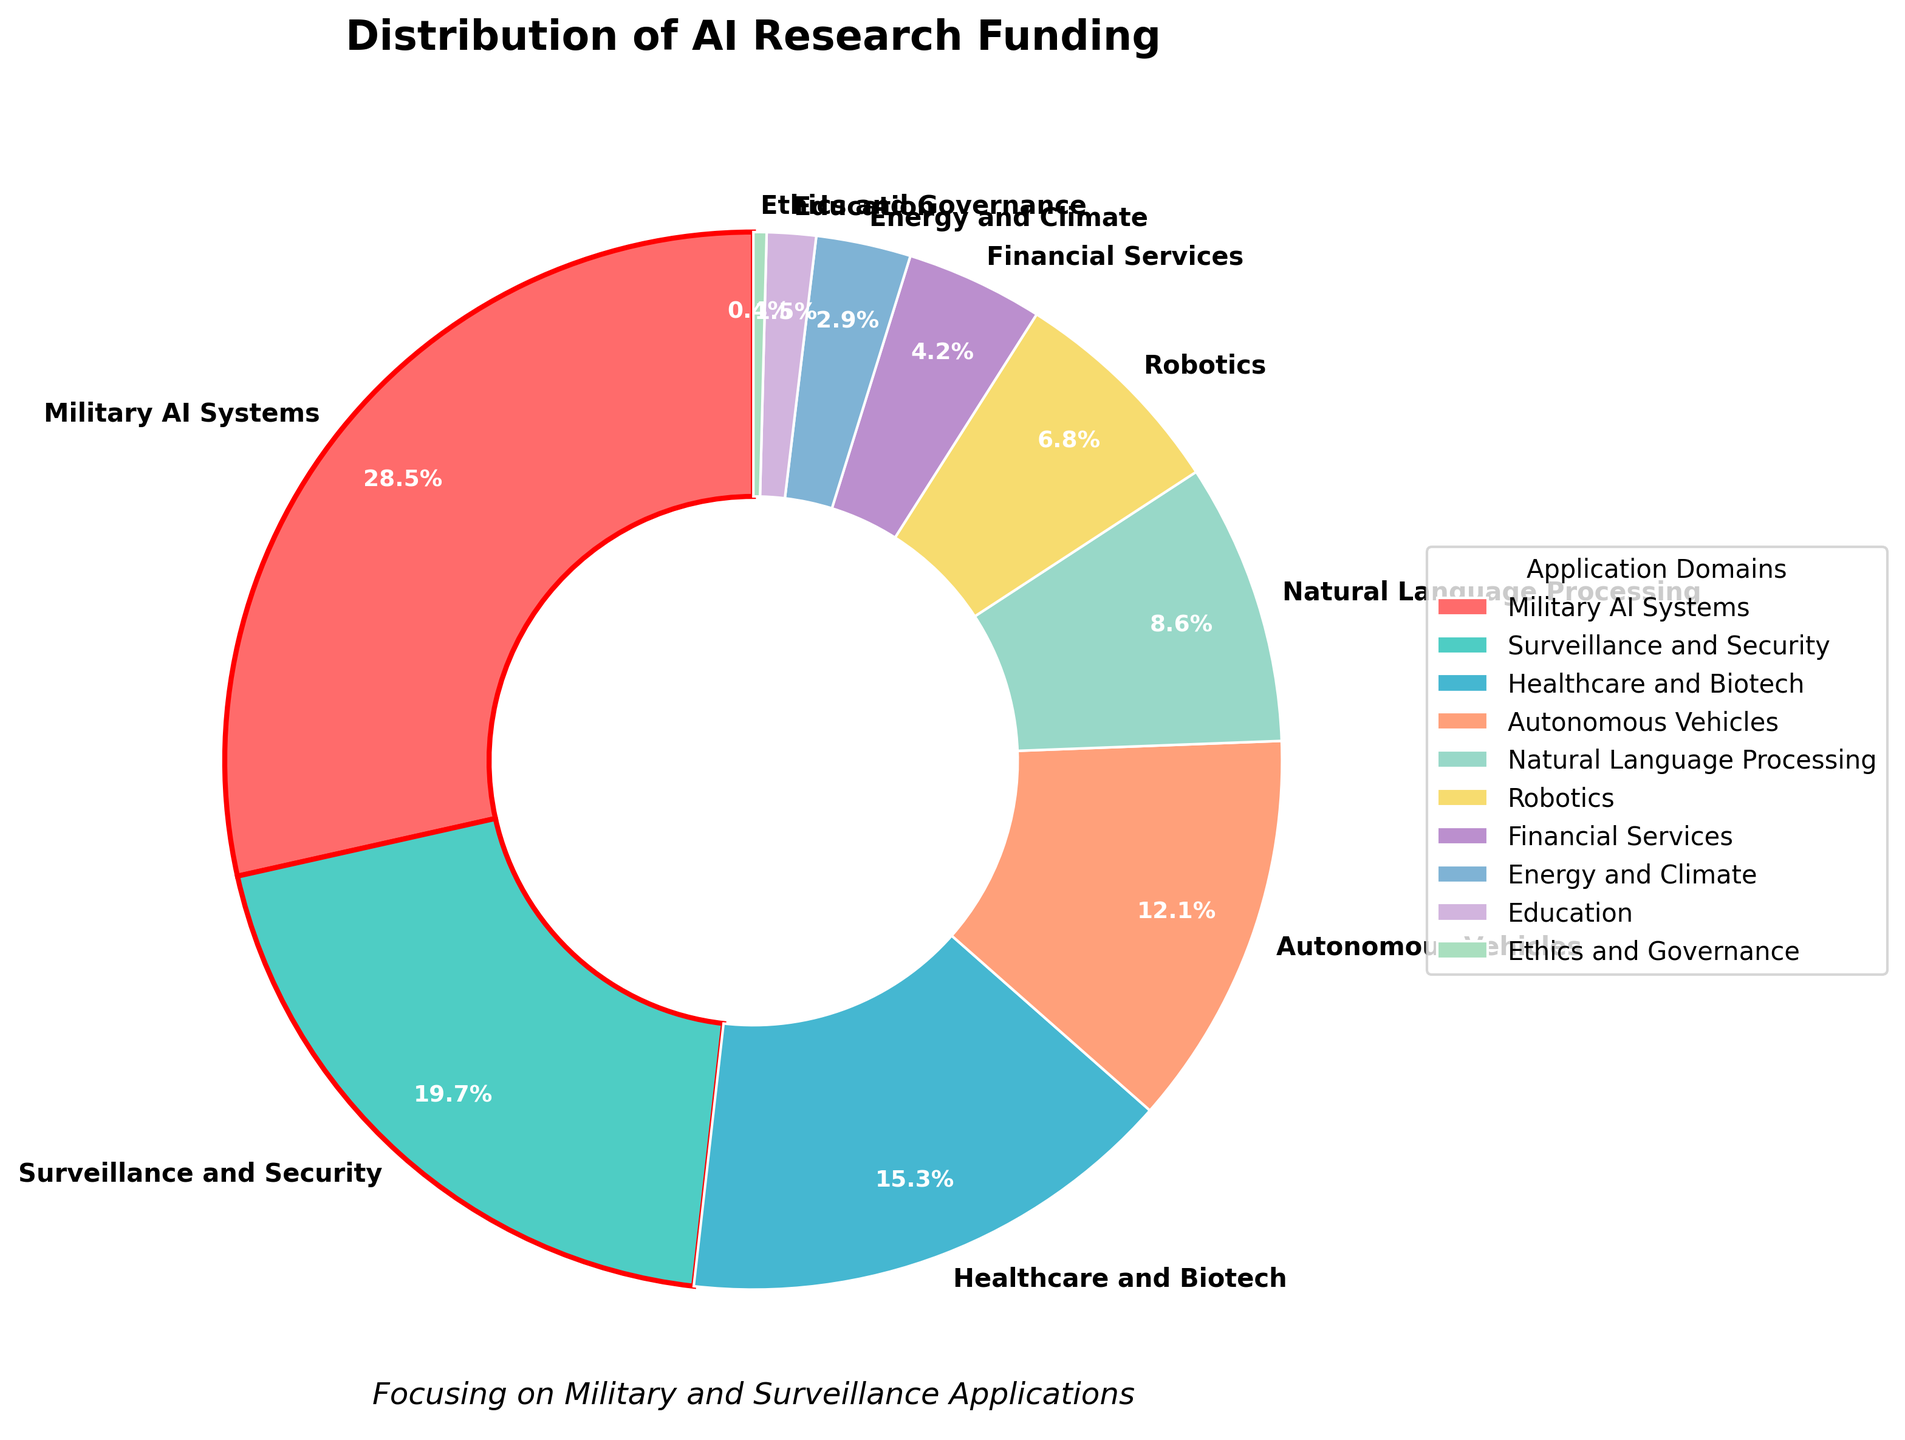What percentage of AI research funding is dedicated to Military AI Systems? The wedge representing Military AI Systems on the pie chart is labeled with a percentage value.
Answer: 28.5% Which application domain receives more funding: Surveillance and Security or Healthcare and Biotech? By examining the labels and corresponding percentage values on the pie chart, Surveillance and Security has 19.7%, while Healthcare and Biotech has 15.3%. Comparing these values, Surveillance and Security receives more funding.
Answer: Surveillance and Security How much more funding does Autonomous Vehicles receive compared to Education? Autonomous Vehicles receives 12.1% and Education receives 1.5%. The difference in funding is calculated as 12.1% - 1.5%.
Answer: 10.6% What is the combined funding percentage for Military AI Systems and Surveillance and Security? To obtain the combined funding for these two domains, add the percentages: 28.5% (Military AI Systems) + 19.7% (Surveillance and Security).
Answer: 48.2% Which domains have funding percentages less than 5%? To determine this, observe the labels on the pie chart and note those with funding percentages less than 5%. These are Financial Services (4.2%), Energy and Climate (2.9%), Education (1.5%), and Ethics and Governance (0.4%).
Answer: Financial Services, Energy and Climate, Education, Ethics and Governance Among Natural Language Processing and Robotics, which has a smaller share of the funding, and by how much? From the chart, Natural Language Processing has 8.6% and Robotics has 6.8%. The difference is calculated as 8.6% - 6.8%. Robotics has a smaller share by 1.8%.
Answer: Robotics, 1.8% Identify the color used to represent Surveillance and Security in the pie chart. By visually inspecting the color of the wedge labeled as Surveillance and Security, it is represented by a specific color.
Answer: Green (or whatever the second color is based on the described color palette) How does the funding for Ethics and Governance compare to Energy and Climate? Ethics and Governance has 0.4% and Energy and Climate has 2.9% funding. Comparing these values, Ethics and Governance receives less funding.
Answer: Ethics and Governance receives less What percentage of the total funding is allocated to domains other than Military AI Systems and Surveillance and Security combined? First, calculate the combined percentage for Military AI Systems (28.5%) and Surveillance and Security (19.7%), which is 48.2%. Subtract this from 100% to find the funding for other domains. 100% - 48.2% = 51.8%.
Answer: 51.8% Which domain receives the lowest percentage of AI research funding, and what is its value? The wedge with the smallest percentage label on the pie chart corresponds to the domain with the lowest funding. This is Ethics and Governance with 0.4%.
Answer: Ethics and Governance, 0.4% 